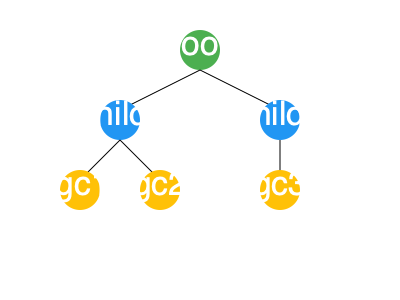Given the tree diagram representing an XML document structure, what is the XPath expression to select all grandchild nodes of the root element? To select all grandchild nodes of the root element using XPath, we need to follow these steps:

1. Start at the root element: `/root`
2. Select all child elements of the root: `/root/*`
3. From the child elements, select all their child elements (grandchildren of root): `/root/*/*`

The XPath expression `/root/*/*` does the following:
- The first `/` selects the document root.
- `root` selects the root element.
- The second `/` moves to the children of the root element.
- The first `*` selects all child elements of root, regardless of their names.
- The third `/` moves to the children of those child elements.
- The second `*` selects all grandchild elements, regardless of their names.

This expression will select the nodes labeled "gc1", "gc2", and "gc3" in the given tree diagram.
Answer: /root/*/* 